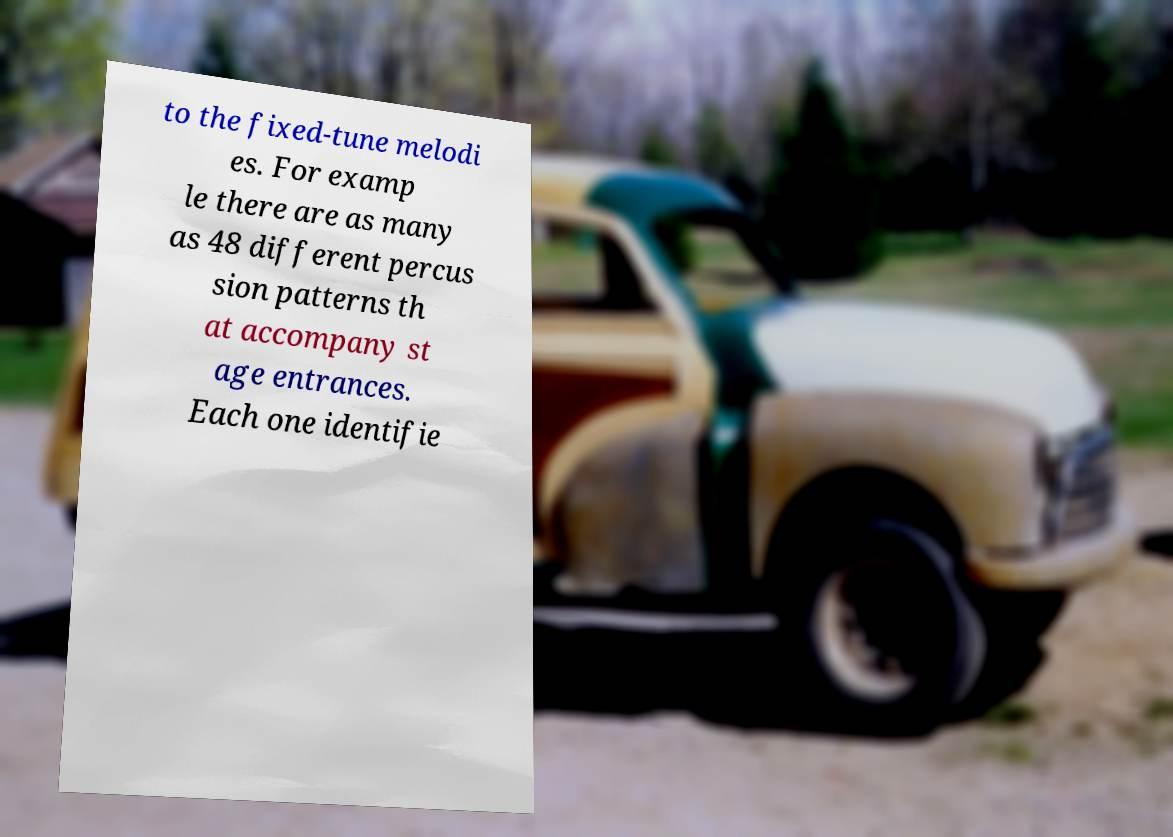Could you assist in decoding the text presented in this image and type it out clearly? to the fixed-tune melodi es. For examp le there are as many as 48 different percus sion patterns th at accompany st age entrances. Each one identifie 